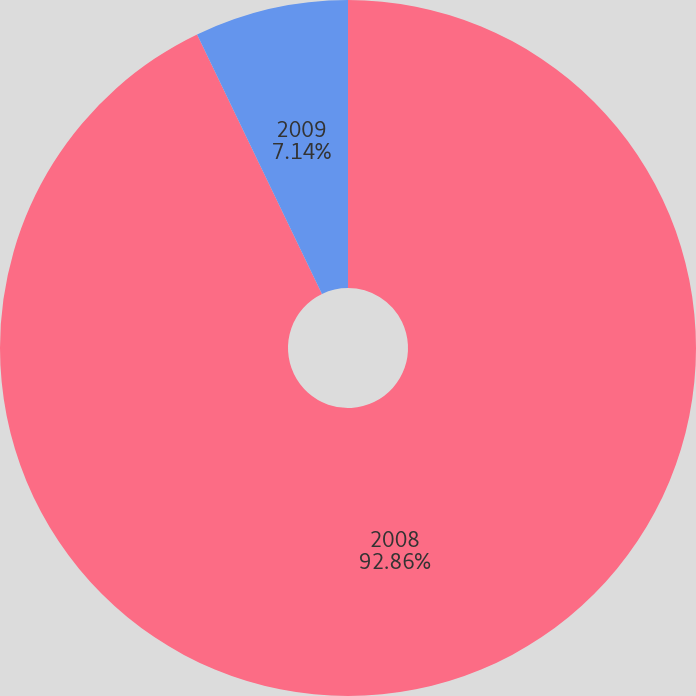Convert chart to OTSL. <chart><loc_0><loc_0><loc_500><loc_500><pie_chart><fcel>2008<fcel>2009<nl><fcel>92.86%<fcel>7.14%<nl></chart> 